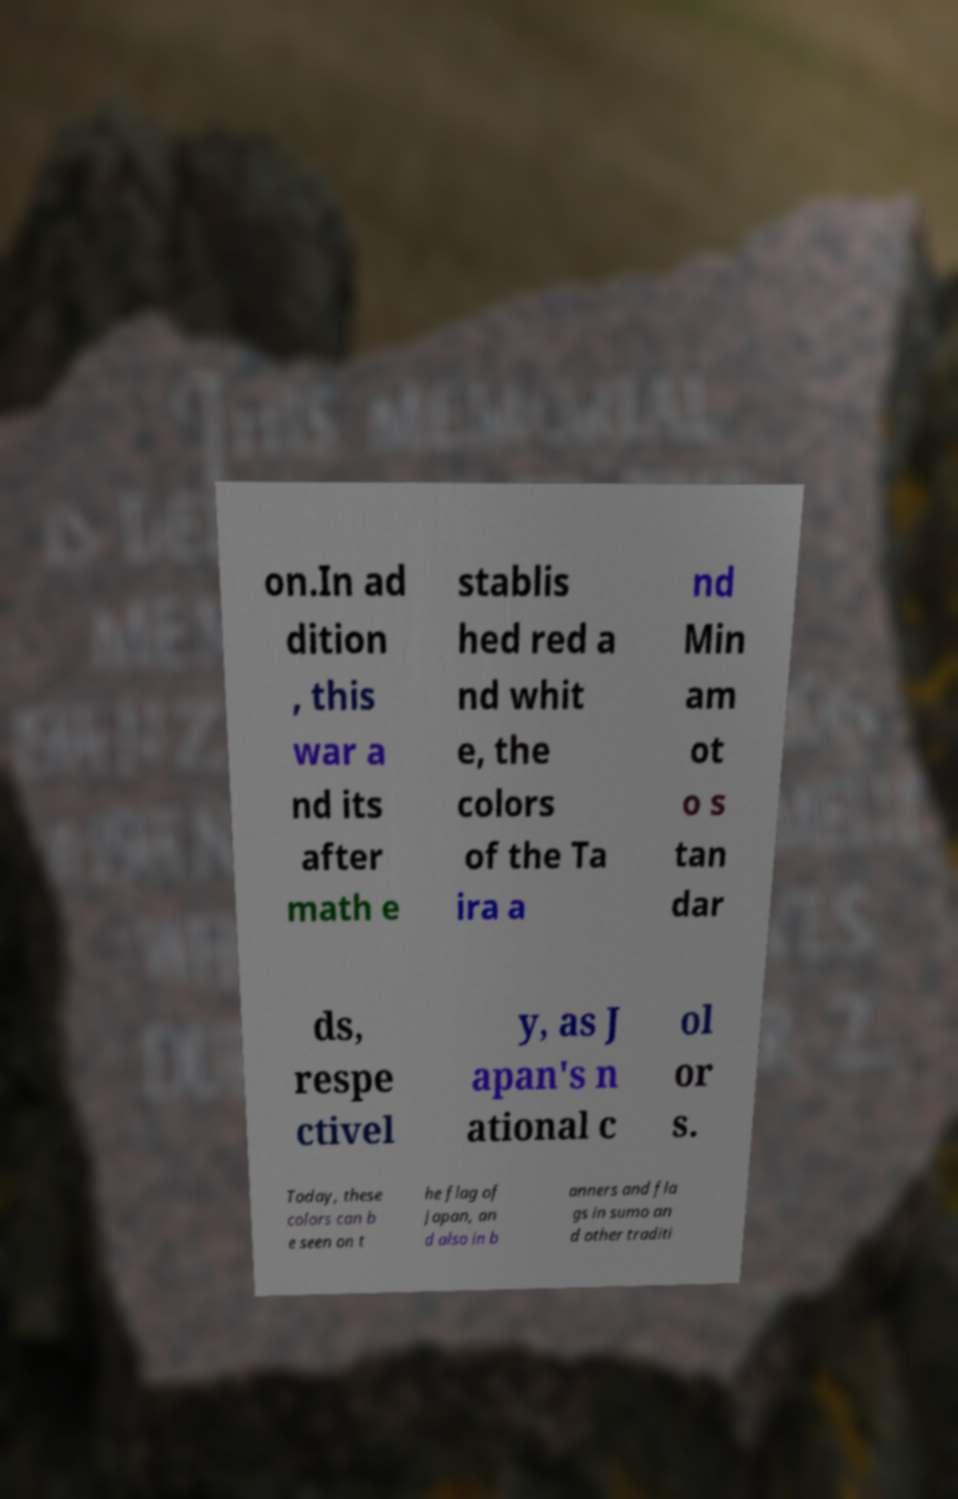I need the written content from this picture converted into text. Can you do that? on.In ad dition , this war a nd its after math e stablis hed red a nd whit e, the colors of the Ta ira a nd Min am ot o s tan dar ds, respe ctivel y, as J apan's n ational c ol or s. Today, these colors can b e seen on t he flag of Japan, an d also in b anners and fla gs in sumo an d other traditi 